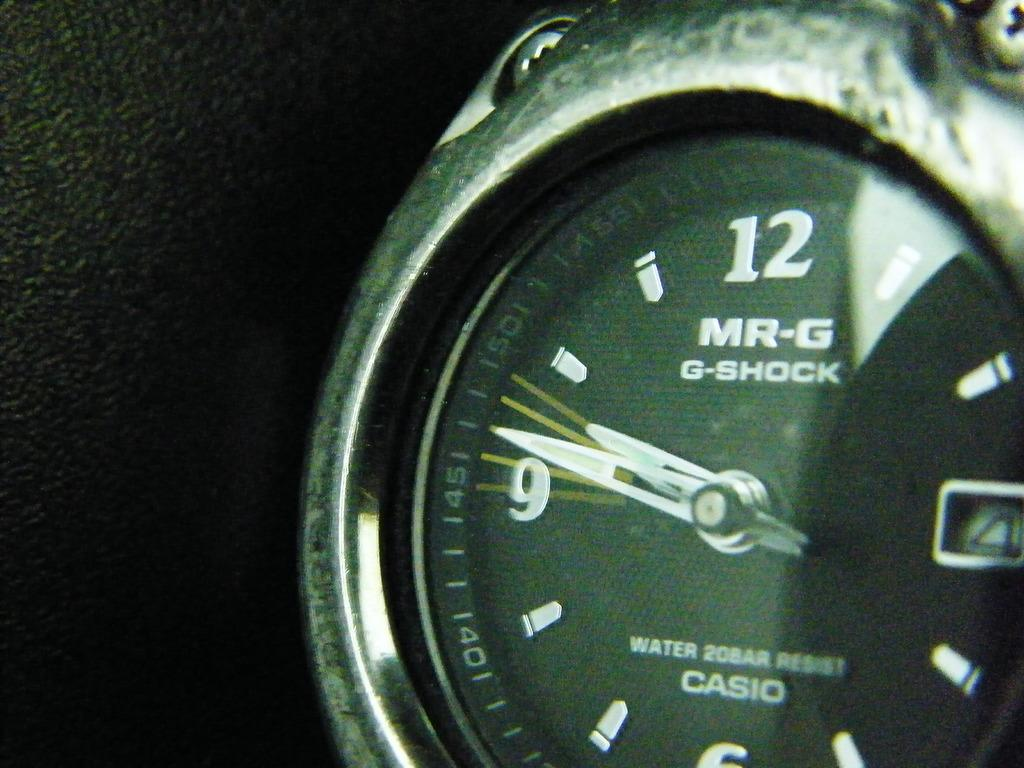<image>
Create a compact narrative representing the image presented. The watch is made by Casio and is a MR-G G-Shock Water 20 Bar Resist brand. 